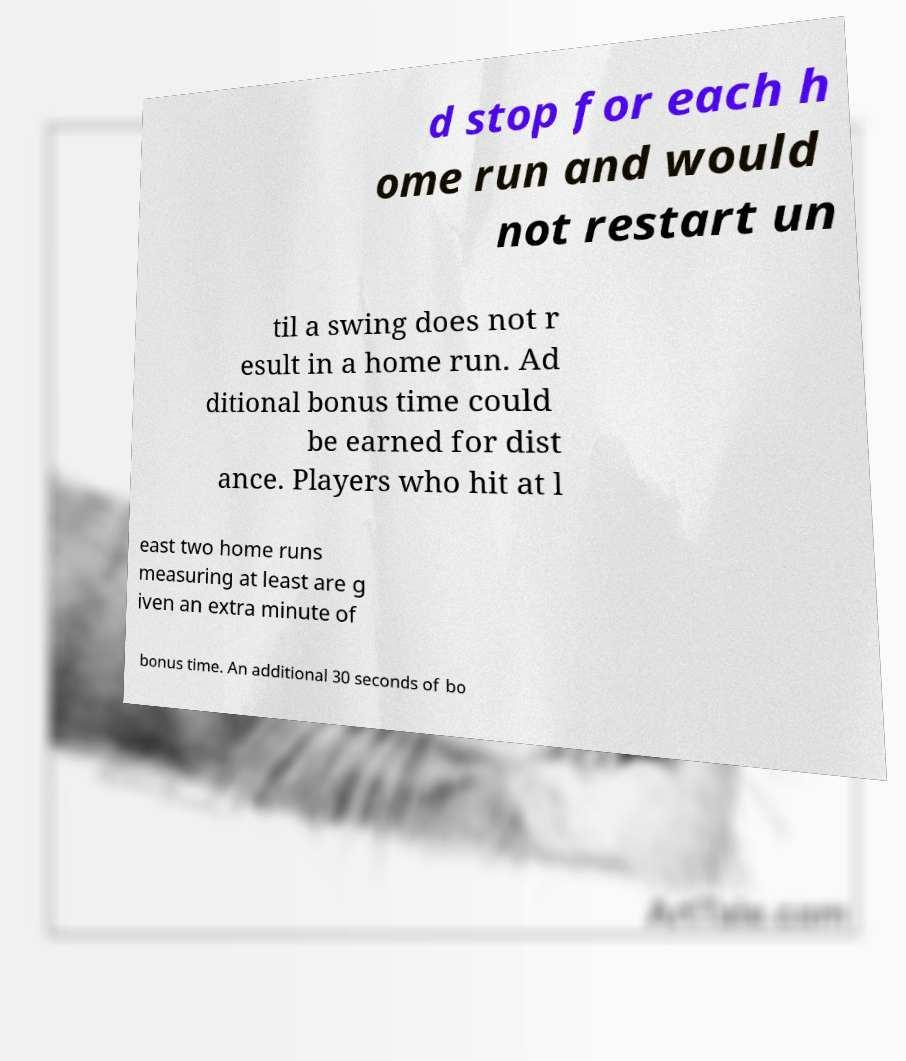What messages or text are displayed in this image? I need them in a readable, typed format. d stop for each h ome run and would not restart un til a swing does not r esult in a home run. Ad ditional bonus time could be earned for dist ance. Players who hit at l east two home runs measuring at least are g iven an extra minute of bonus time. An additional 30 seconds of bo 